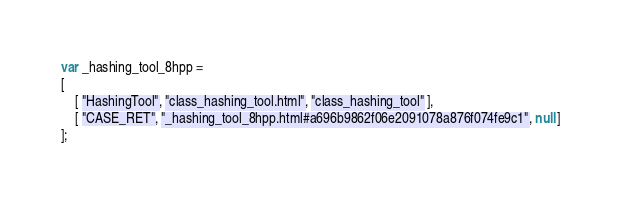Convert code to text. <code><loc_0><loc_0><loc_500><loc_500><_JavaScript_>var _hashing_tool_8hpp =
[
    [ "HashingTool", "class_hashing_tool.html", "class_hashing_tool" ],
    [ "CASE_RET", "_hashing_tool_8hpp.html#a696b9862f06e2091078a876f074fe9c1", null ]
];</code> 